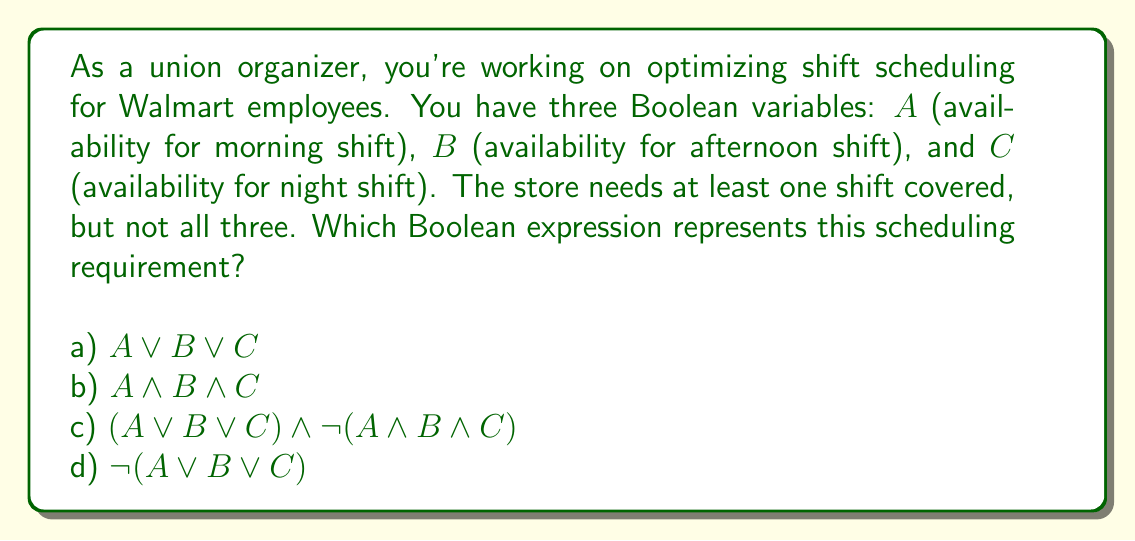Give your solution to this math problem. Let's break this down step-by-step:

1) We need at least one shift covered, which means $A$ OR $B$ OR $C$ must be true. This is represented by $A \lor B \lor C$.

2) However, we don't want all three shifts covered by the same person. This means we need to exclude the case where $A$ AND $B$ AND $C$ are all true, which is represented by $\lnot(A \land B \land C)$.

3) To combine these two conditions, we use the AND operator:
   $(A \lor B \lor C) \land \lnot(A \land B \land C)$

4) This expression ensures that:
   - At least one shift is covered: $(A \lor B \lor C)$
   - Not all shifts are covered by the same person: $\lnot(A \land B \land C)$

5) Let's evaluate the options:
   a) $A \lor B \lor C$ - This only ensures at least one shift is covered, but doesn't prevent all shifts being covered.
   b) $A \land B \land C$ - This requires all shifts to be covered, which is not what we want.
   c) $(A \lor B \lor C) \land \lnot(A \land B \land C)$ - This matches our requirements exactly.
   d) $\lnot(A \lor B \lor C)$ - This ensures no shifts are covered, which is not what we want.

Therefore, the correct answer is option c.
Answer: c) $(A \lor B \lor C) \land \lnot(A \land B \land C)$ 